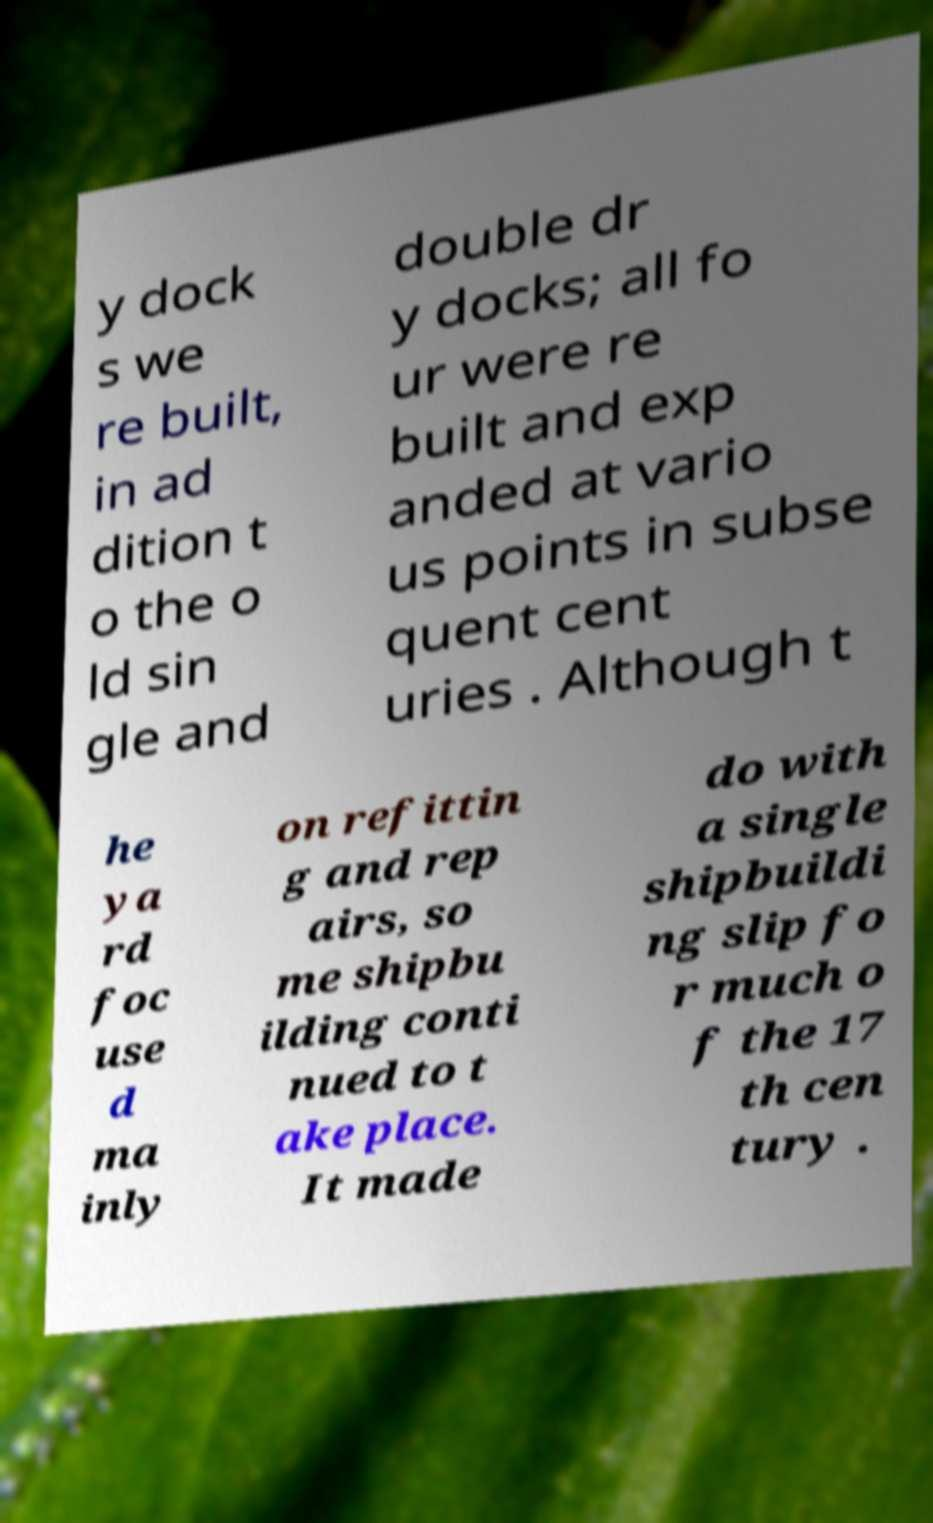Could you extract and type out the text from this image? y dock s we re built, in ad dition t o the o ld sin gle and double dr y docks; all fo ur were re built and exp anded at vario us points in subse quent cent uries . Although t he ya rd foc use d ma inly on refittin g and rep airs, so me shipbu ilding conti nued to t ake place. It made do with a single shipbuildi ng slip fo r much o f the 17 th cen tury . 